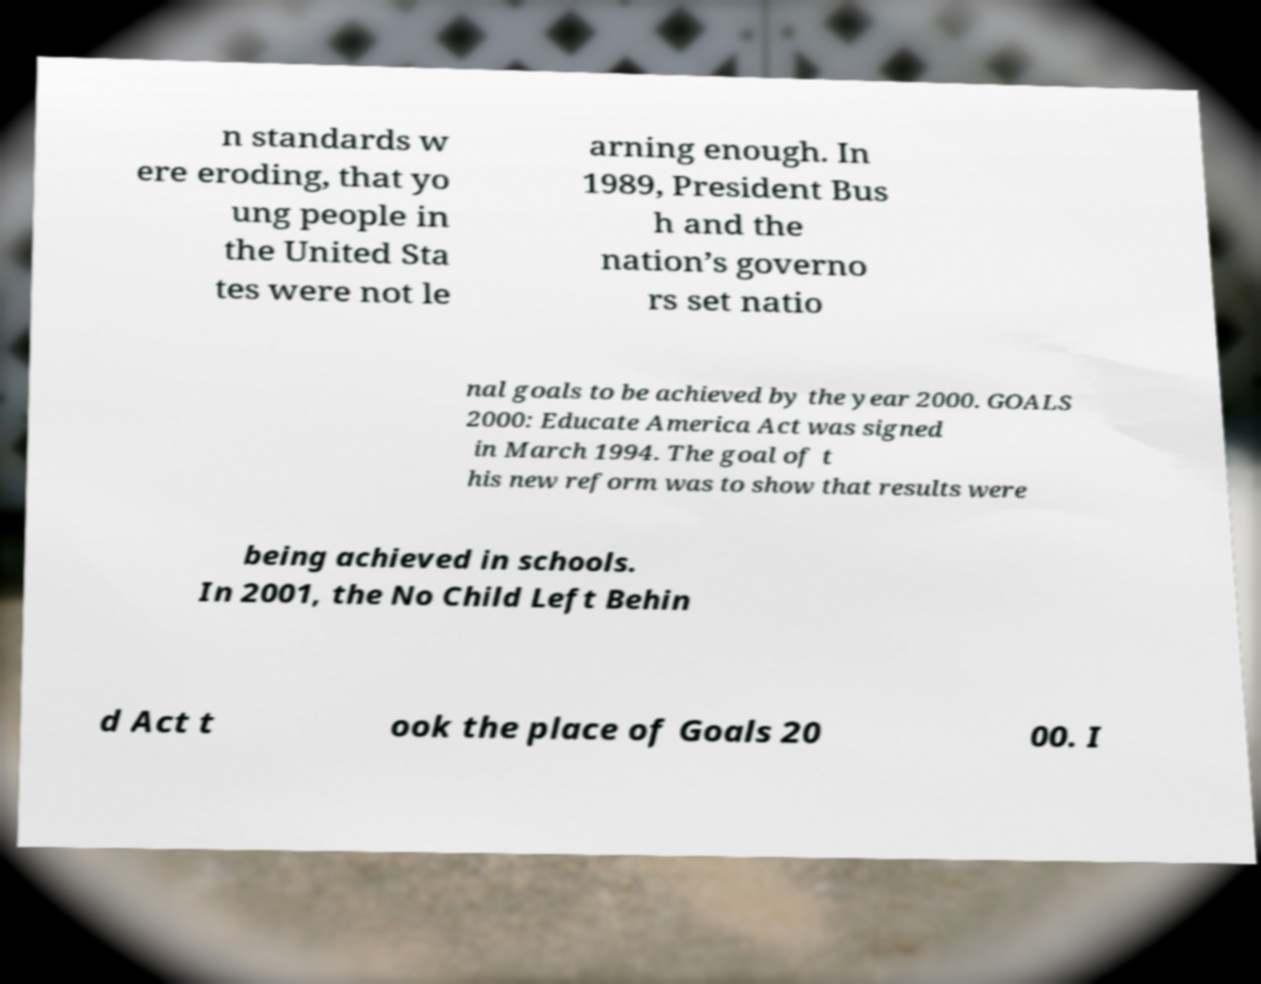Could you assist in decoding the text presented in this image and type it out clearly? n standards w ere eroding, that yo ung people in the United Sta tes were not le arning enough. In 1989, President Bus h and the nation’s governo rs set natio nal goals to be achieved by the year 2000. GOALS 2000: Educate America Act was signed in March 1994. The goal of t his new reform was to show that results were being achieved in schools. In 2001, the No Child Left Behin d Act t ook the place of Goals 20 00. I 